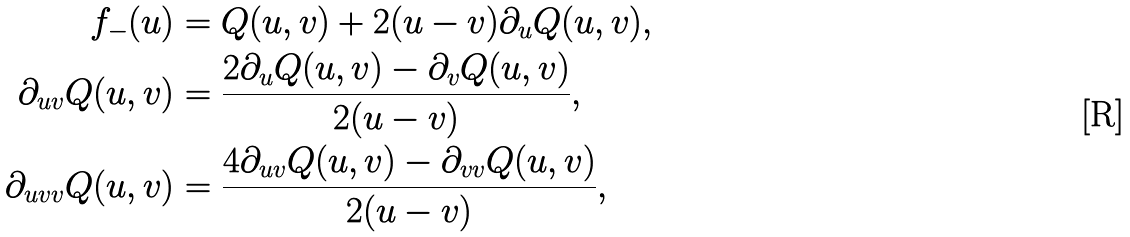Convert formula to latex. <formula><loc_0><loc_0><loc_500><loc_500>f _ { - } ( u ) & = Q ( u , v ) + 2 ( u - v ) \partial _ { u } Q ( u , v ) , \\ \partial _ { u v } Q ( u , v ) & = \frac { 2 \partial _ { u } Q ( u , v ) - \partial _ { v } Q ( u , v ) } { 2 ( u - v ) } , \\ \partial _ { u v v } Q ( u , v ) & = \frac { 4 \partial _ { u v } Q ( u , v ) - \partial _ { v v } Q ( u , v ) } { 2 ( u - v ) } ,</formula> 